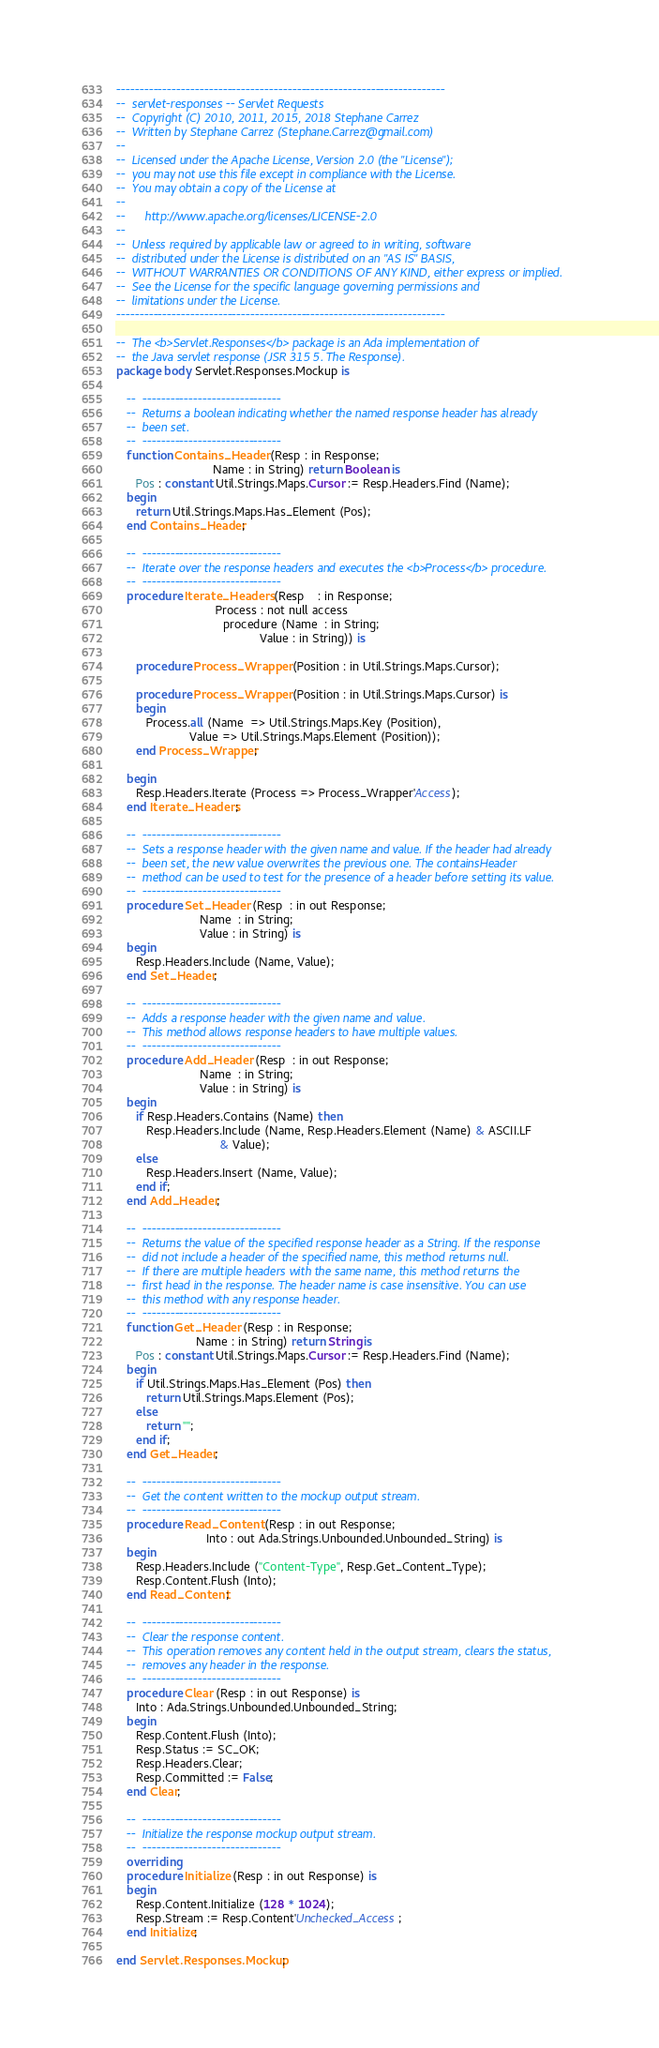Convert code to text. <code><loc_0><loc_0><loc_500><loc_500><_Ada_>-----------------------------------------------------------------------
--  servlet-responses -- Servlet Requests
--  Copyright (C) 2010, 2011, 2015, 2018 Stephane Carrez
--  Written by Stephane Carrez (Stephane.Carrez@gmail.com)
--
--  Licensed under the Apache License, Version 2.0 (the "License");
--  you may not use this file except in compliance with the License.
--  You may obtain a copy of the License at
--
--      http://www.apache.org/licenses/LICENSE-2.0
--
--  Unless required by applicable law or agreed to in writing, software
--  distributed under the License is distributed on an "AS IS" BASIS,
--  WITHOUT WARRANTIES OR CONDITIONS OF ANY KIND, either express or implied.
--  See the License for the specific language governing permissions and
--  limitations under the License.
-----------------------------------------------------------------------

--  The <b>Servlet.Responses</b> package is an Ada implementation of
--  the Java servlet response (JSR 315 5. The Response).
package body Servlet.Responses.Mockup is

   --  ------------------------------
   --  Returns a boolean indicating whether the named response header has already
   --  been set.
   --  ------------------------------
   function Contains_Header (Resp : in Response;
                             Name : in String) return Boolean is
      Pos : constant Util.Strings.Maps.Cursor := Resp.Headers.Find (Name);
   begin
      return Util.Strings.Maps.Has_Element (Pos);
   end Contains_Header;

   --  ------------------------------
   --  Iterate over the response headers and executes the <b>Process</b> procedure.
   --  ------------------------------
   procedure Iterate_Headers (Resp    : in Response;
                              Process : not null access
                                procedure (Name  : in String;
                                           Value : in String)) is

      procedure Process_Wrapper (Position : in Util.Strings.Maps.Cursor);

      procedure Process_Wrapper (Position : in Util.Strings.Maps.Cursor) is
      begin
         Process.all (Name  => Util.Strings.Maps.Key (Position),
                      Value => Util.Strings.Maps.Element (Position));
      end Process_Wrapper;

   begin
      Resp.Headers.Iterate (Process => Process_Wrapper'Access);
   end Iterate_Headers;

   --  ------------------------------
   --  Sets a response header with the given name and value. If the header had already
   --  been set, the new value overwrites the previous one. The containsHeader
   --  method can be used to test for the presence of a header before setting its value.
   --  ------------------------------
   procedure Set_Header (Resp  : in out Response;
                         Name  : in String;
                         Value : in String) is
   begin
      Resp.Headers.Include (Name, Value);
   end Set_Header;

   --  ------------------------------
   --  Adds a response header with the given name and value.
   --  This method allows response headers to have multiple values.
   --  ------------------------------
   procedure Add_Header (Resp  : in out Response;
                         Name  : in String;
                         Value : in String) is
   begin
      if Resp.Headers.Contains (Name) then
         Resp.Headers.Include (Name, Resp.Headers.Element (Name) & ASCII.LF
                               & Value);
      else
         Resp.Headers.Insert (Name, Value);
      end if;
   end Add_Header;

   --  ------------------------------
   --  Returns the value of the specified response header as a String. If the response
   --  did not include a header of the specified name, this method returns null.
   --  If there are multiple headers with the same name, this method returns the
   --  first head in the response. The header name is case insensitive. You can use
   --  this method with any response header.
   --  ------------------------------
   function Get_Header (Resp : in Response;
                        Name : in String) return String is
      Pos : constant Util.Strings.Maps.Cursor := Resp.Headers.Find (Name);
   begin
      if Util.Strings.Maps.Has_Element (Pos) then
         return Util.Strings.Maps.Element (Pos);
      else
         return "";
      end if;
   end Get_Header;

   --  ------------------------------
   --  Get the content written to the mockup output stream.
   --  ------------------------------
   procedure Read_Content (Resp : in out Response;
                           Into : out Ada.Strings.Unbounded.Unbounded_String) is
   begin
      Resp.Headers.Include ("Content-Type", Resp.Get_Content_Type);
      Resp.Content.Flush (Into);
   end Read_Content;

   --  ------------------------------
   --  Clear the response content.
   --  This operation removes any content held in the output stream, clears the status,
   --  removes any header in the response.
   --  ------------------------------
   procedure Clear (Resp : in out Response) is
      Into : Ada.Strings.Unbounded.Unbounded_String;
   begin
      Resp.Content.Flush (Into);
      Resp.Status := SC_OK;
      Resp.Headers.Clear;
      Resp.Committed := False;
   end Clear;

   --  ------------------------------
   --  Initialize the response mockup output stream.
   --  ------------------------------
   overriding
   procedure Initialize (Resp : in out Response) is
   begin
      Resp.Content.Initialize (128 * 1024);
      Resp.Stream := Resp.Content'Unchecked_Access;
   end Initialize;

end Servlet.Responses.Mockup;
</code> 